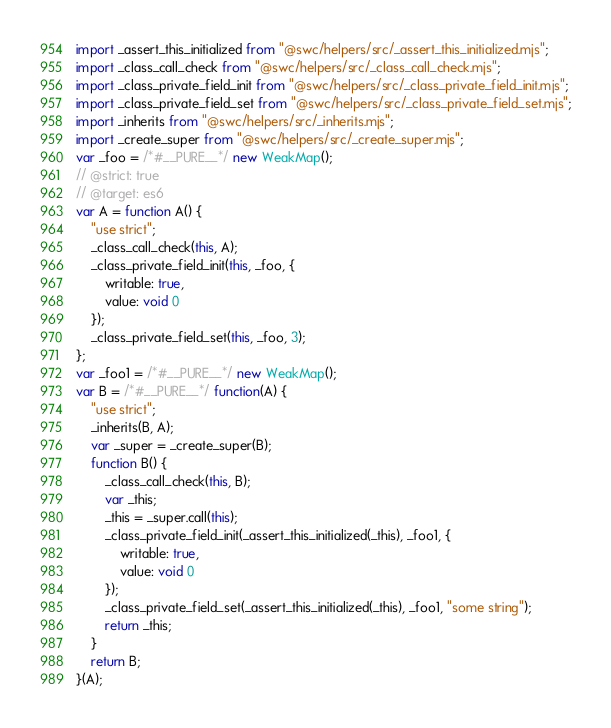Convert code to text. <code><loc_0><loc_0><loc_500><loc_500><_JavaScript_>import _assert_this_initialized from "@swc/helpers/src/_assert_this_initialized.mjs";
import _class_call_check from "@swc/helpers/src/_class_call_check.mjs";
import _class_private_field_init from "@swc/helpers/src/_class_private_field_init.mjs";
import _class_private_field_set from "@swc/helpers/src/_class_private_field_set.mjs";
import _inherits from "@swc/helpers/src/_inherits.mjs";
import _create_super from "@swc/helpers/src/_create_super.mjs";
var _foo = /*#__PURE__*/ new WeakMap();
// @strict: true
// @target: es6
var A = function A() {
    "use strict";
    _class_call_check(this, A);
    _class_private_field_init(this, _foo, {
        writable: true,
        value: void 0
    });
    _class_private_field_set(this, _foo, 3);
};
var _foo1 = /*#__PURE__*/ new WeakMap();
var B = /*#__PURE__*/ function(A) {
    "use strict";
    _inherits(B, A);
    var _super = _create_super(B);
    function B() {
        _class_call_check(this, B);
        var _this;
        _this = _super.call(this);
        _class_private_field_init(_assert_this_initialized(_this), _foo1, {
            writable: true,
            value: void 0
        });
        _class_private_field_set(_assert_this_initialized(_this), _foo1, "some string");
        return _this;
    }
    return B;
}(A);
</code> 